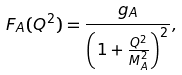Convert formula to latex. <formula><loc_0><loc_0><loc_500><loc_500>F _ { A } ( Q ^ { 2 } ) = \frac { g _ { A } } { \left ( 1 + \frac { Q ^ { 2 } } { M _ { A } ^ { 2 } } \right ) ^ { 2 } } ,</formula> 